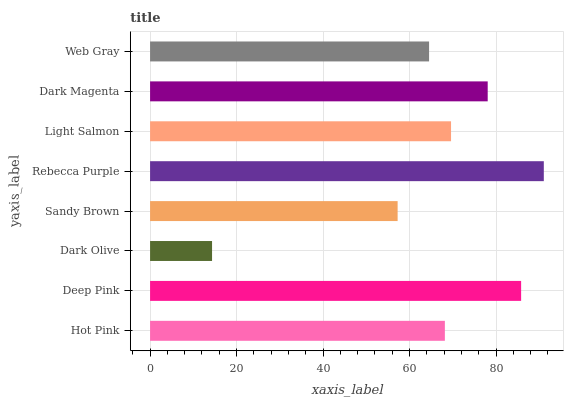Is Dark Olive the minimum?
Answer yes or no. Yes. Is Rebecca Purple the maximum?
Answer yes or no. Yes. Is Deep Pink the minimum?
Answer yes or no. No. Is Deep Pink the maximum?
Answer yes or no. No. Is Deep Pink greater than Hot Pink?
Answer yes or no. Yes. Is Hot Pink less than Deep Pink?
Answer yes or no. Yes. Is Hot Pink greater than Deep Pink?
Answer yes or no. No. Is Deep Pink less than Hot Pink?
Answer yes or no. No. Is Light Salmon the high median?
Answer yes or no. Yes. Is Hot Pink the low median?
Answer yes or no. Yes. Is Deep Pink the high median?
Answer yes or no. No. Is Dark Olive the low median?
Answer yes or no. No. 